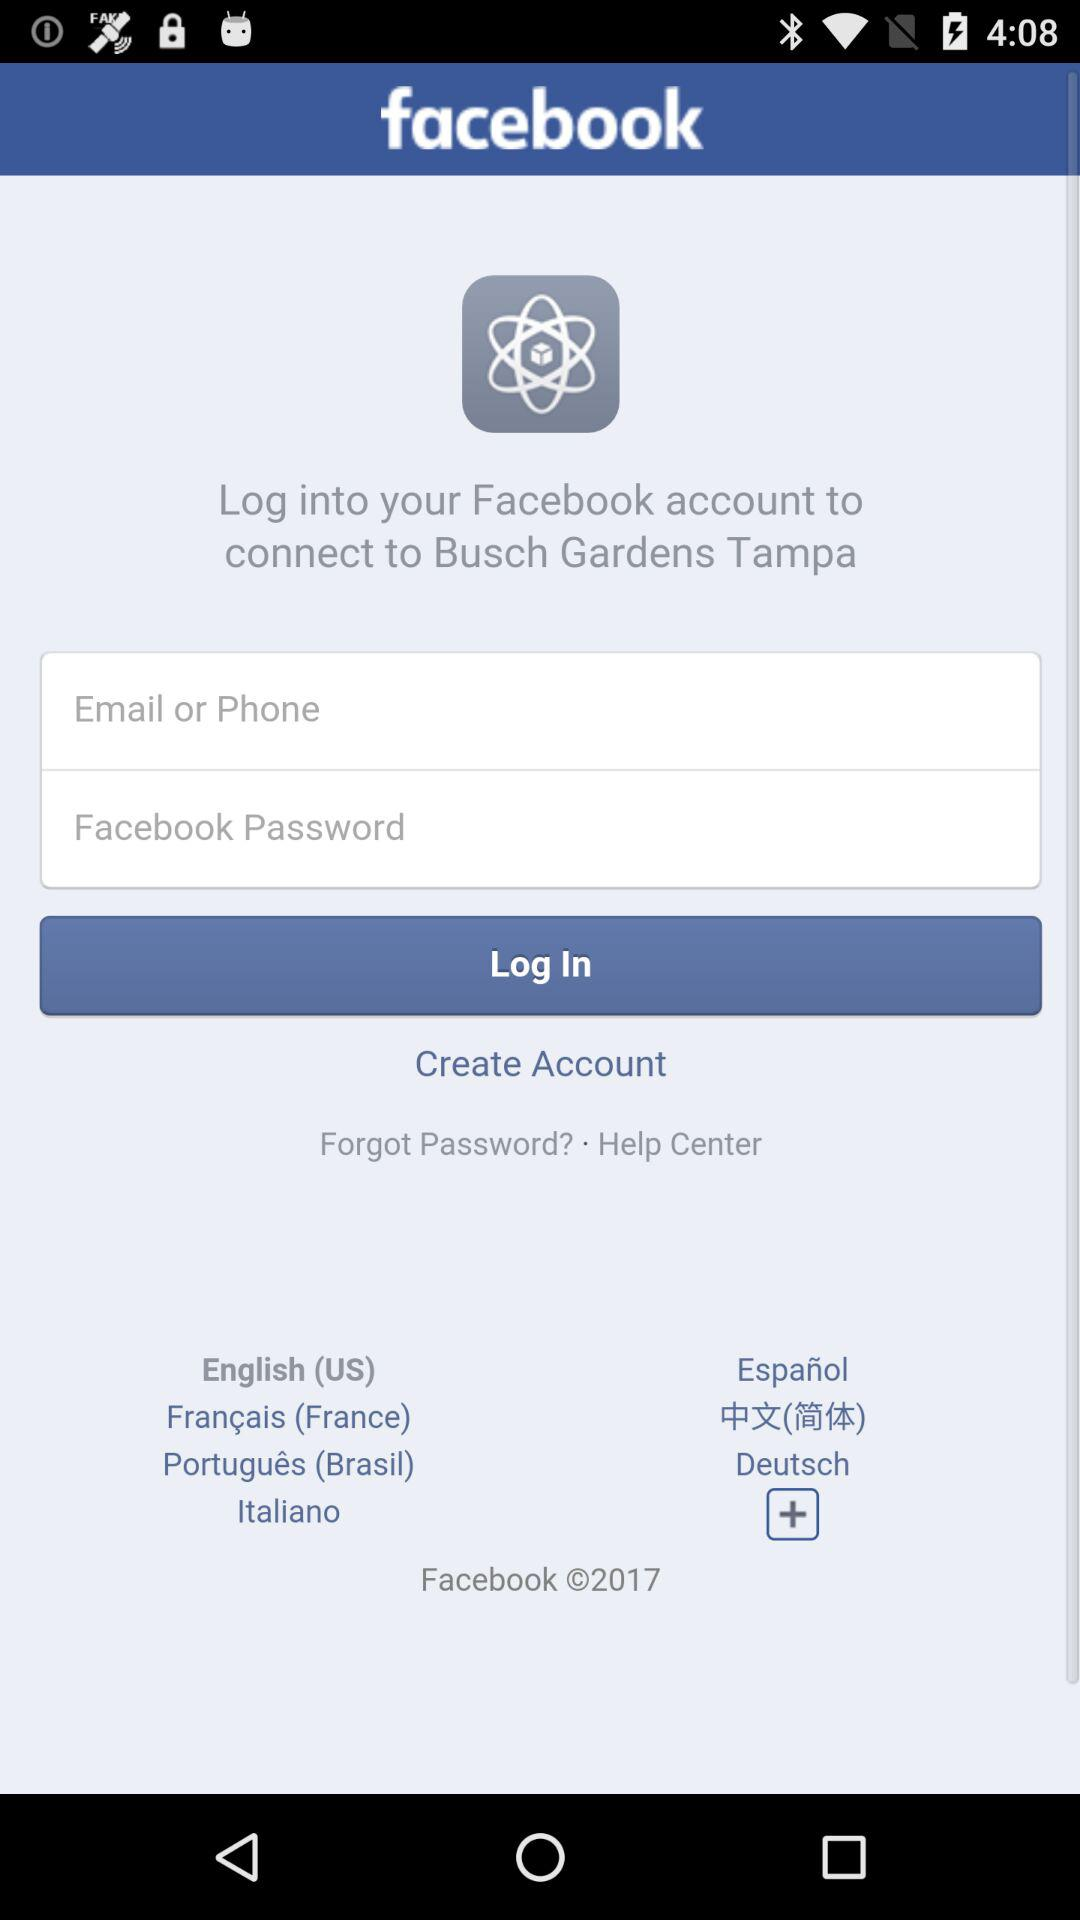Through what app can you log in to connect to "Busch Gardens Tampa"? You can log in through "facebook" to connect to "Busch Gardens Tampa". 